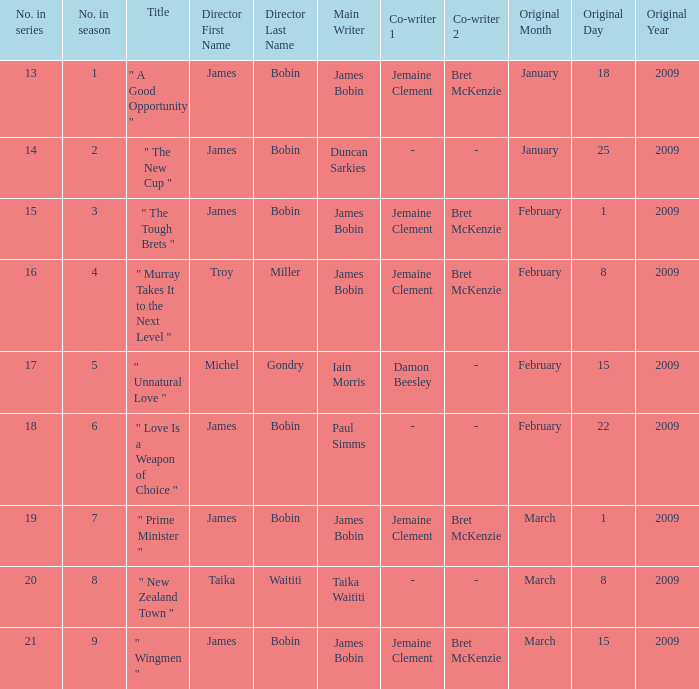 what's the title where original air date is january18,2009 " A Good Opportunity ". Could you parse the entire table as a dict? {'header': ['No. in series', 'No. in season', 'Title', 'Director First Name', 'Director Last Name', 'Main Writer', 'Co-writer 1', 'Co-writer 2', 'Original Month', 'Original Day', 'Original Year'], 'rows': [['13', '1', '" A Good Opportunity "', 'James', 'Bobin', 'James Bobin', 'Jemaine Clement', 'Bret McKenzie', 'January', '18', '2009'], ['14', '2', '" The New Cup "', 'James', 'Bobin', 'Duncan Sarkies', '-', '-', 'January', '25', '2009'], ['15', '3', '" The Tough Brets "', 'James', 'Bobin', 'James Bobin', 'Jemaine Clement', 'Bret McKenzie', 'February', '1', '2009'], ['16', '4', '" Murray Takes It to the Next Level "', 'Troy', 'Miller', 'James Bobin', 'Jemaine Clement', 'Bret McKenzie', 'February', '8', '2009'], ['17', '5', '" Unnatural Love "', 'Michel', 'Gondry', 'Iain Morris', 'Damon Beesley', '-', 'February', '15', '2009'], ['18', '6', '" Love Is a Weapon of Choice "', 'James', 'Bobin', 'Paul Simms', '-', '-', 'February', '22', '2009'], ['19', '7', '" Prime Minister "', 'James', 'Bobin', 'James Bobin', 'Jemaine Clement', 'Bret McKenzie', 'March', '1', '2009'], ['20', '8', '" New Zealand Town "', 'Taika', 'Waititi', 'Taika Waititi', '-', '-', 'March', '8', '2009'], ['21', '9', '" Wingmen "', 'James', 'Bobin', 'James Bobin', 'Jemaine Clement', 'Bret McKenzie', 'March', '15', '2009']]} 